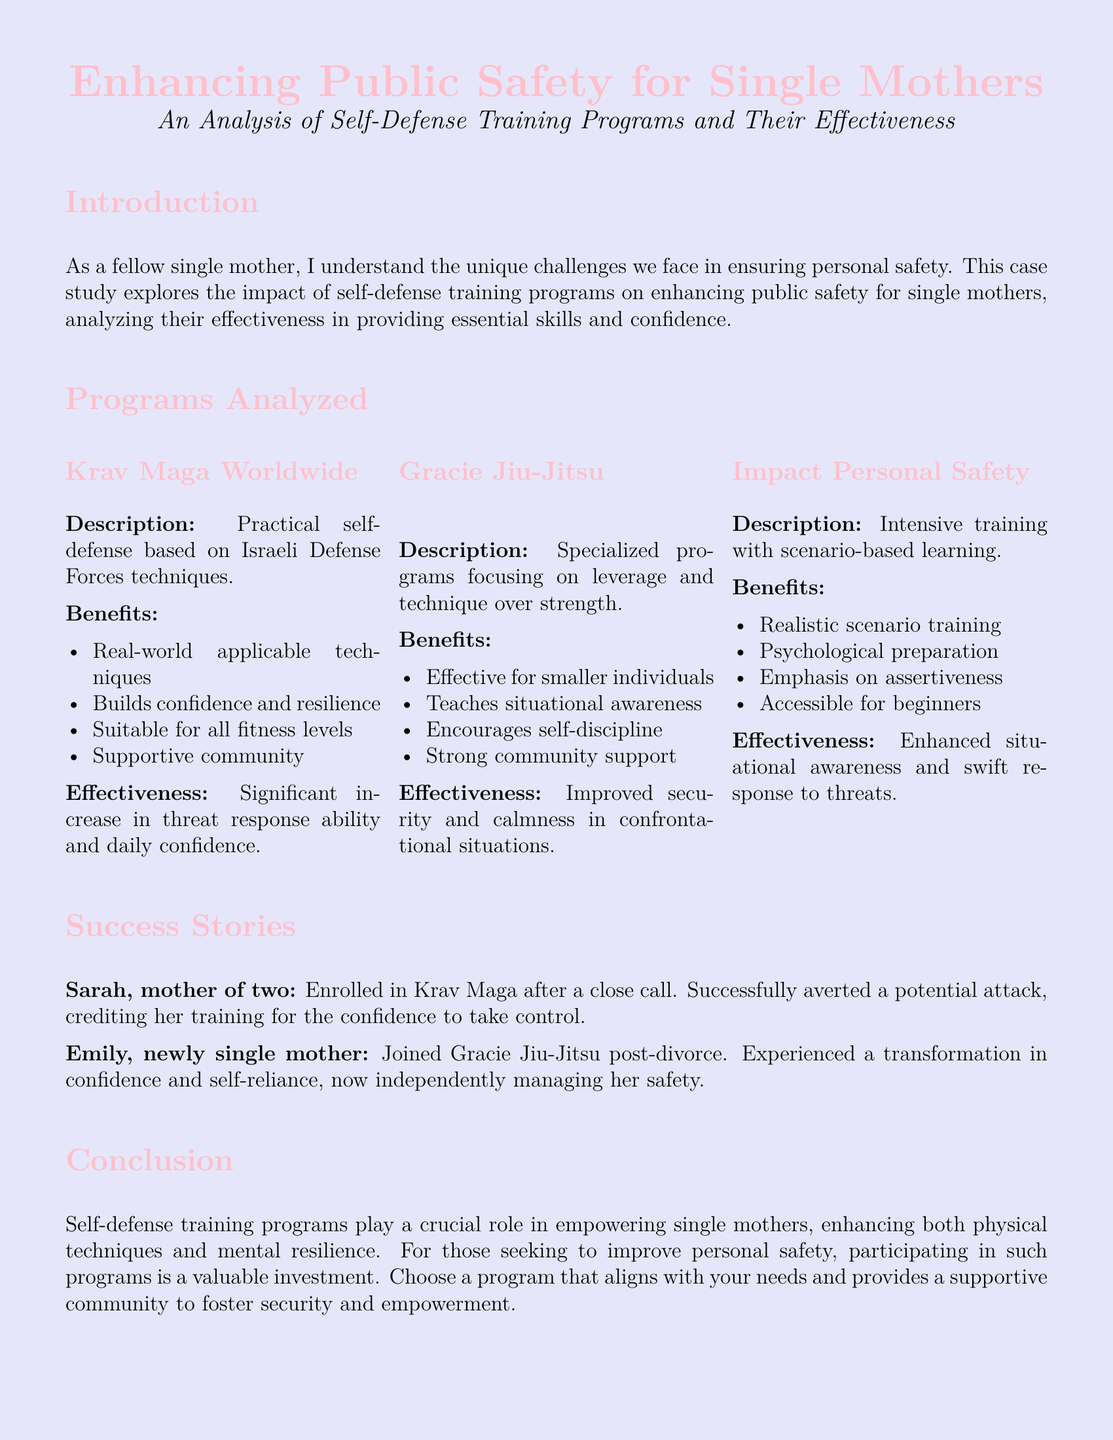What is the title of the case study? The title is presented prominently at the top of the document.
Answer: Enhancing Public Safety for Single Mothers How many self-defense programs are analyzed in the case study? The section on programs analyzed lists three distinct self-defense training programs.
Answer: Three What is a benefit of Krav Maga Worldwide? Benefits are listed under each program; one of the benefits highlights its applicability.
Answer: Real-world applicable techniques Who experienced a transformation in confidence and self-reliance? The success stories mention individuals by name, focusing on their experiences.
Answer: Emily What type of training does Impact Personal Safety emphasize? The description of the program indicates its focus area as per the outlined benefits.
Answer: Assertiveness What is a significant outcome reported from Gracie Jiu-Jitsu? The effectiveness of the program discusses enhancements in personal security.
Answer: Improved security What does the conclusion recommend for single mothers? The conclusion emphasizes the importance of engaging in specific activities for personal growth.
Answer: Participating in self-defense programs What does self-defense training enhance according to the conclusion? The conclusion summarizes the benefits discussed throughout the case study, highlighting skills.
Answer: Physical techniques and mental resilience 